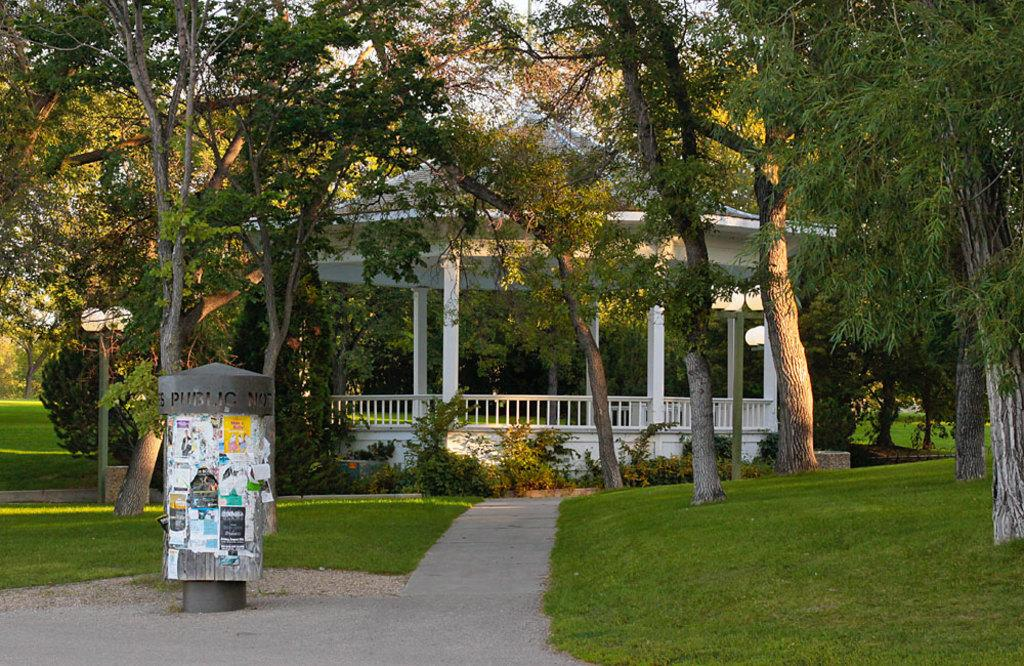What is the object that has papers attached to it in the image? The information provided does not specify the object with the papers attached. What can be found in the image besides papers? There are poles, lights, plants, grass, a gazebo, and trees in the background of the image. What type of lighting is present in the image? There are lights in the image, but the specific type of lighting is not mentioned. What type of vegetation is present in the image? There are plants and trees in the image. What type of structure is present in the image? There is a gazebo in the image. What is the background of the image? The background of the image includes trees. What color is the crayon used to draw on the ground in the image? There is no crayon or drawing on the ground in the image. What type of bag is hanging on the poles in the image? There are no bags hanging on the poles in the image. 